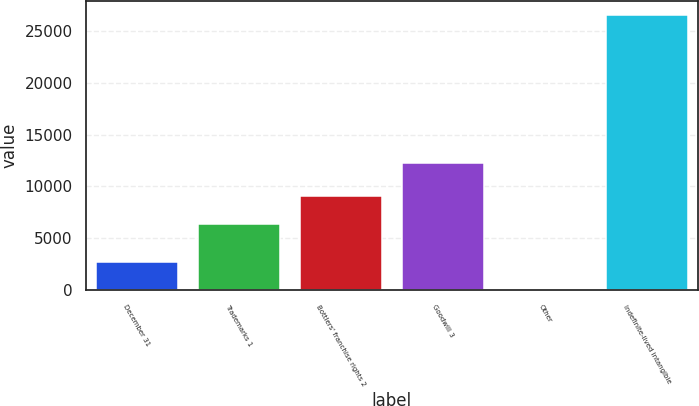Convert chart. <chart><loc_0><loc_0><loc_500><loc_500><bar_chart><fcel>December 31<fcel>Trademarks 1<fcel>Bottlers' franchise rights 2<fcel>Goodwill 3<fcel>Other<fcel>Indefinite-lived intangible<nl><fcel>2754.9<fcel>6430<fcel>9071.9<fcel>12219<fcel>113<fcel>26532<nl></chart> 